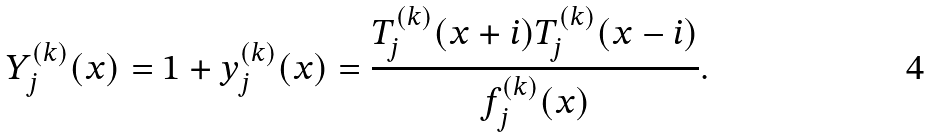Convert formula to latex. <formula><loc_0><loc_0><loc_500><loc_500>Y ^ { ( k ) } _ { j } ( x ) = 1 + y ^ { ( k ) } _ { j } ( x ) = \frac { T ^ { ( k ) } _ { j } ( x + i ) T ^ { ( k ) } _ { j } ( x - i ) } { f ^ { ( k ) } _ { j } ( x ) } .</formula> 